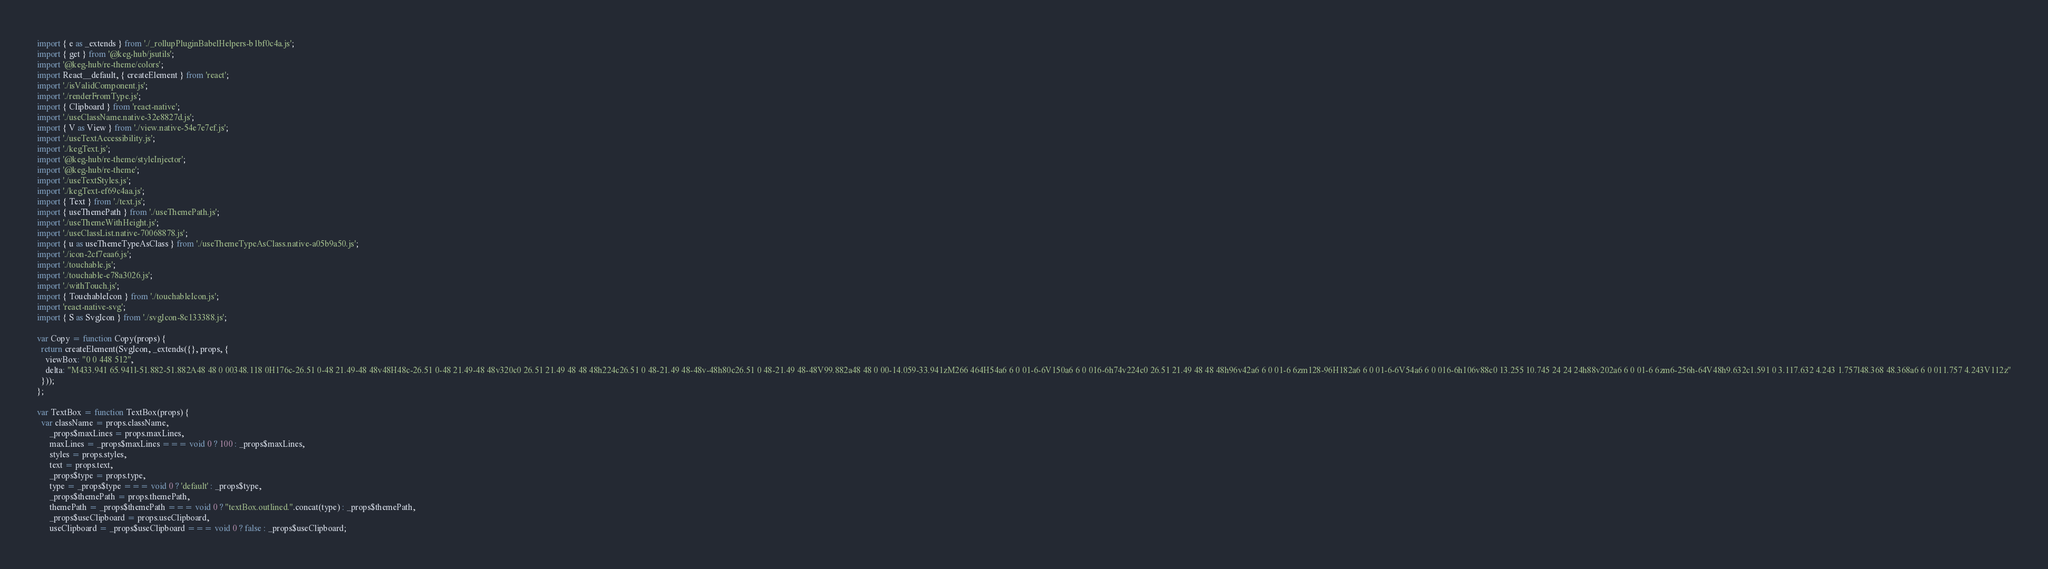<code> <loc_0><loc_0><loc_500><loc_500><_JavaScript_>import { e as _extends } from './_rollupPluginBabelHelpers-b1bf0c4a.js';
import { get } from '@keg-hub/jsutils';
import '@keg-hub/re-theme/colors';
import React__default, { createElement } from 'react';
import './isValidComponent.js';
import './renderFromType.js';
import { Clipboard } from 'react-native';
import './useClassName.native-32e8827d.js';
import { V as View } from './view.native-54e7e7ef.js';
import './useTextAccessibility.js';
import './kegText.js';
import '@keg-hub/re-theme/styleInjector';
import '@keg-hub/re-theme';
import './useTextStyles.js';
import './kegText-ef69c4aa.js';
import { Text } from './text.js';
import { useThemePath } from './useThemePath.js';
import './useThemeWithHeight.js';
import './useClassList.native-70068878.js';
import { u as useThemeTypeAsClass } from './useThemeTypeAsClass.native-a05b9a50.js';
import './icon-2cf7eaa6.js';
import './touchable.js';
import './touchable-e78a3026.js';
import './withTouch.js';
import { TouchableIcon } from './touchableIcon.js';
import 'react-native-svg';
import { S as SvgIcon } from './svgIcon-8c133388.js';

var Copy = function Copy(props) {
  return createElement(SvgIcon, _extends({}, props, {
    viewBox: "0 0 448 512",
    delta: "M433.941 65.941l-51.882-51.882A48 48 0 00348.118 0H176c-26.51 0-48 21.49-48 48v48H48c-26.51 0-48 21.49-48 48v320c0 26.51 21.49 48 48 48h224c26.51 0 48-21.49 48-48v-48h80c26.51 0 48-21.49 48-48V99.882a48 48 0 00-14.059-33.941zM266 464H54a6 6 0 01-6-6V150a6 6 0 016-6h74v224c0 26.51 21.49 48 48 48h96v42a6 6 0 01-6 6zm128-96H182a6 6 0 01-6-6V54a6 6 0 016-6h106v88c0 13.255 10.745 24 24 24h88v202a6 6 0 01-6 6zm6-256h-64V48h9.632c1.591 0 3.117.632 4.243 1.757l48.368 48.368a6 6 0 011.757 4.243V112z"
  }));
};

var TextBox = function TextBox(props) {
  var className = props.className,
      _props$maxLines = props.maxLines,
      maxLines = _props$maxLines === void 0 ? 100 : _props$maxLines,
      styles = props.styles,
      text = props.text,
      _props$type = props.type,
      type = _props$type === void 0 ? 'default' : _props$type,
      _props$themePath = props.themePath,
      themePath = _props$themePath === void 0 ? "textBox.outlined.".concat(type) : _props$themePath,
      _props$useClipboard = props.useClipboard,
      useClipboard = _props$useClipboard === void 0 ? false : _props$useClipboard;</code> 